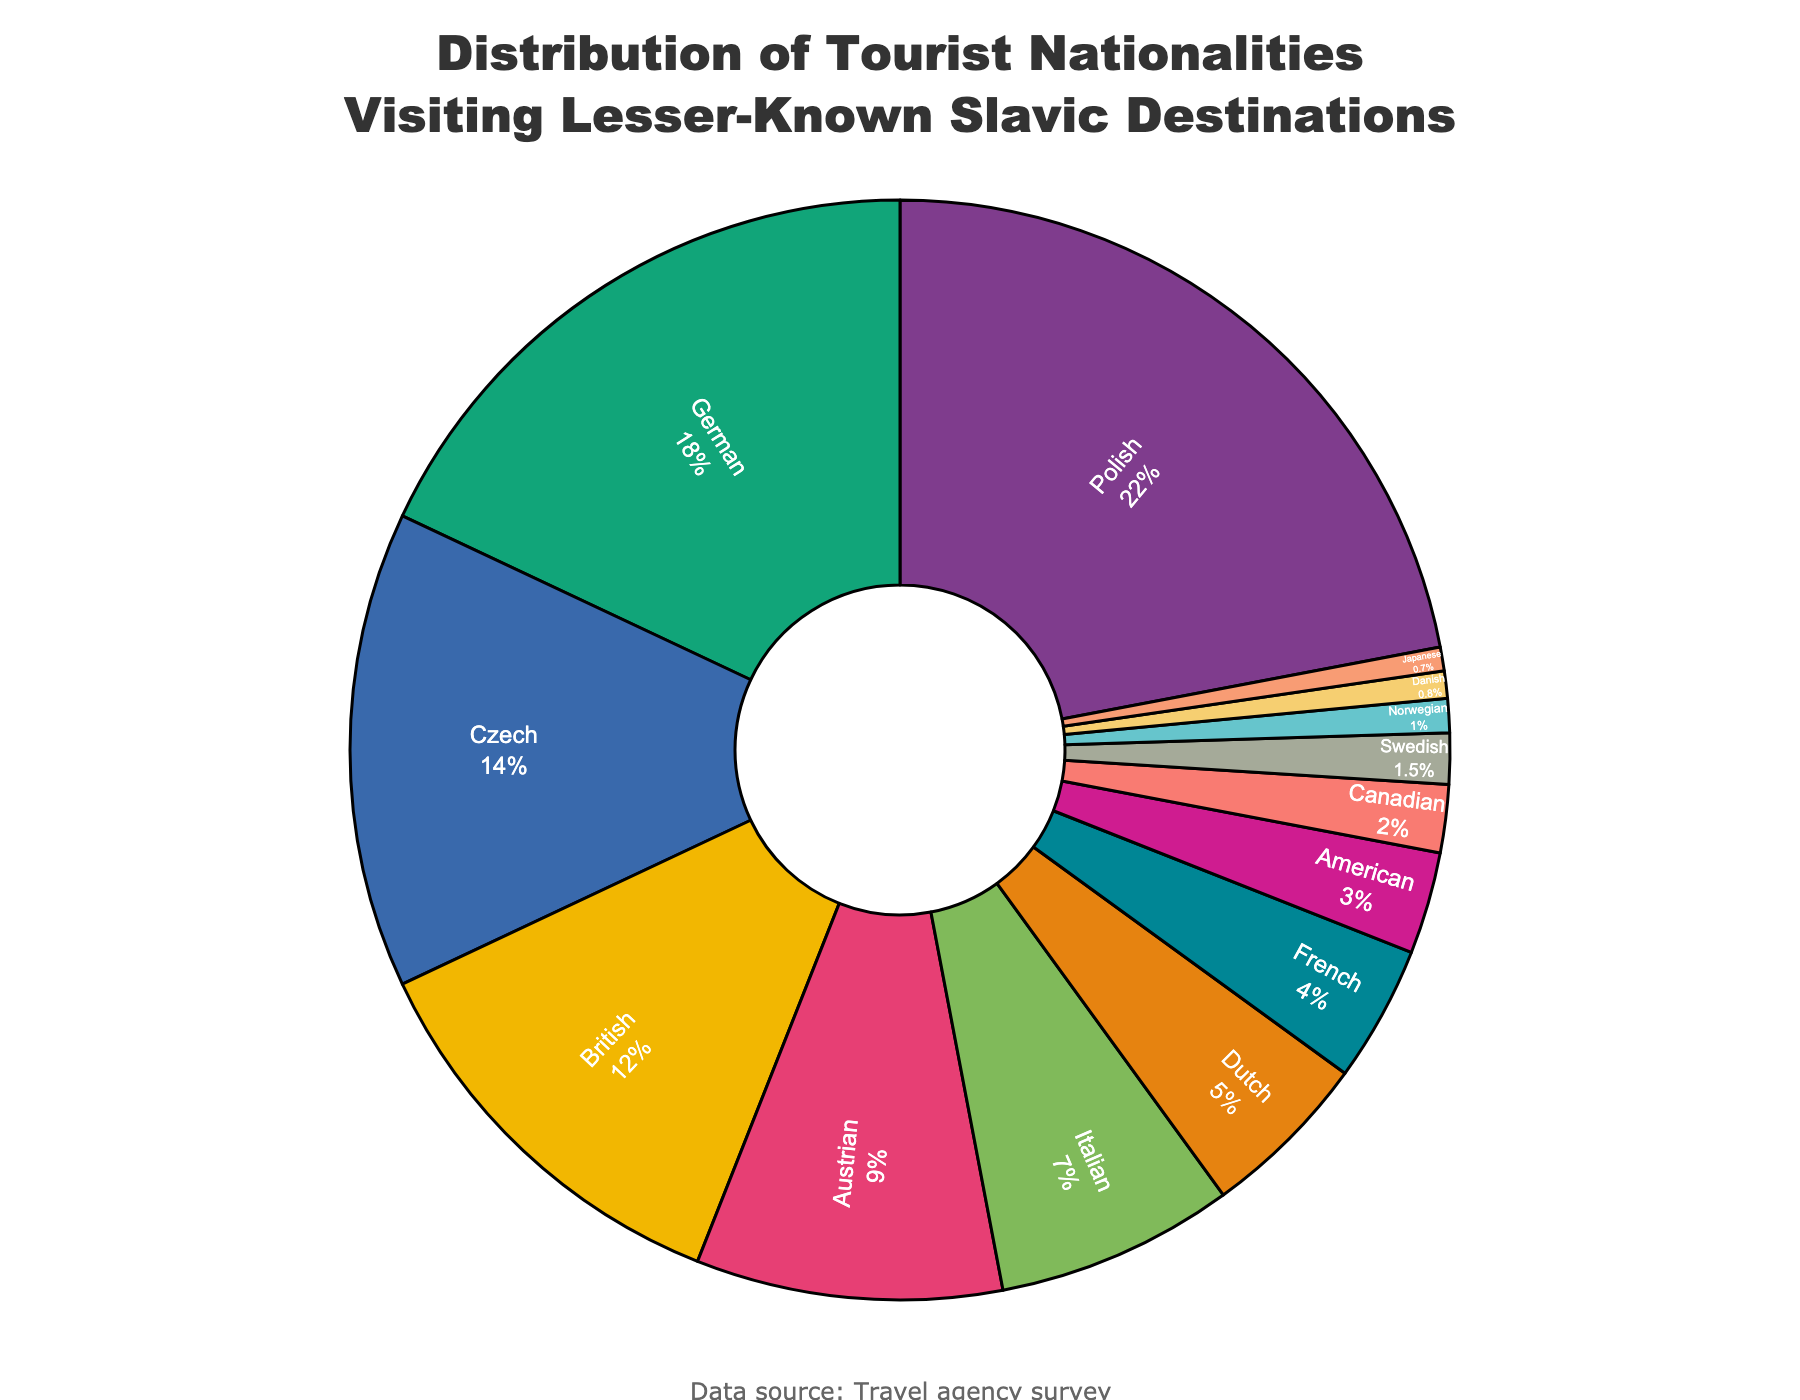What percentage of tourists are German and Canadian combined? From the pie chart, German tourists make up 18% and Canadian tourists make up 2%. Adding these percentages together gives 18% + 2% = 20%.
Answer: 20% Which nationality comprises a higher percentage of tourists, Italian or Dutch? The pie chart shows that Italian tourists make up 7%, while Dutch tourists make up 5%. Since 7% is greater than 5%, Italian tourists comprise a higher percentage.
Answer: Italian What is the difference in percentage between Polish and British tourists? From the pie chart, Polish tourists account for 22%, and British tourists account for 12%. The difference in percentage is 22% - 12% = 10%.
Answer: 10% What is the combined percentage of tourists from Scandinavian countries (Swedish, Norwegian, and Danish)? From the pie chart, the percentages are Swedish (1.5%), Norwegian (1%), and Danish (0.8%). The combined percentage is 1.5% + 1% + 0.8% = 3.3%.
Answer: 3.3% Which group is smaller, American or French tourists, and by how much? The pie chart shows American tourists at 3% and French tourists at 4%. The difference is 4% - 3% = 1%. Therefore, American tourists are smaller by 1%.
Answer: American, 1% Which nationalities have a percentage below 2%? From the pie chart, the nationalities with a percentage below 2% are Swedish (1.5%), Norwegian (1%), Danish (0.8%), and Japanese (0.7%).
Answer: Swedish, Norwegian, Danish, Japanese How much larger is the percentage of Polish tourists compared to Dutch tourists? The pie chart indicates that Polish tourists make up 22%, while Dutch tourists make up 5%. The difference is 22% - 5% = 17%.
Answer: 17% What is the average percentage of tourists for Italian, Dutch, and French nationalities? From the pie chart, the percentages are Italian (7%), Dutch (5%), and French (4%). The average is calculated as (7% + 5% + 4%) / 3 = 16% / 3 ≈ 5.33%.
Answer: 5.33% If the Japanese tourist percentage doubled, what would it be? From the pie chart, Japanese tourists make up 0.7%. If this number doubled, it would be 0.7% × 2 = 1.4%.
Answer: 1.4% 